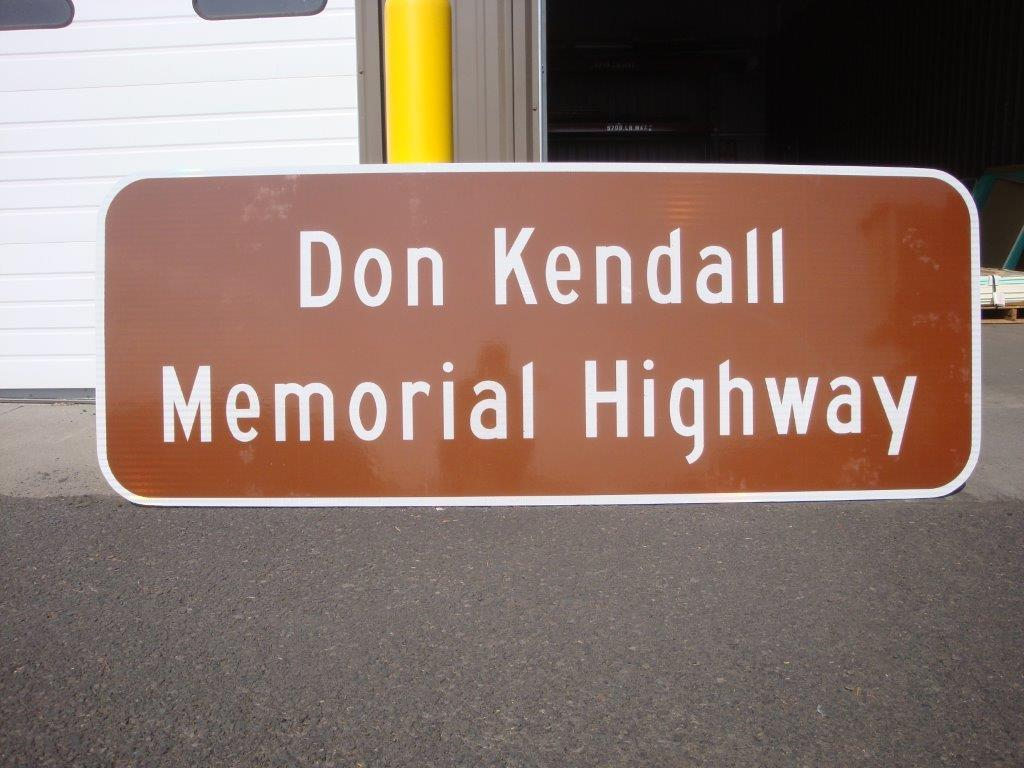<image>
Render a clear and concise summary of the photo. A brown sign for a memorial highway leans against a yellow pole. 